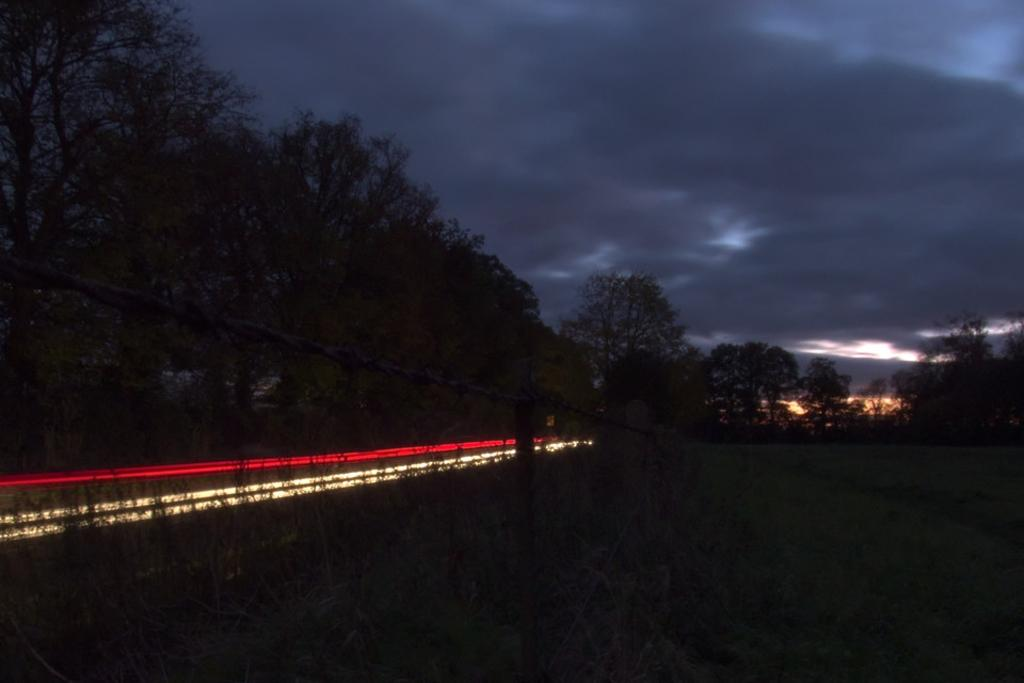What is located at the bottom of the image? There is a net at the bottom of the image. What can be seen in the image besides the net? There are lights, plants, and grass visible in the image. What type of vegetation is in the background of the image? There are trees in the background of the image. What is visible at the top of the image? The sky is visible at the top of the image. What type of stove is used in the image? There is no stove present in the image. 